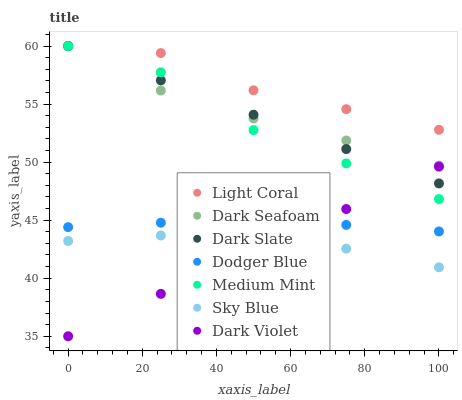Does Dark Violet have the minimum area under the curve?
Answer yes or no. Yes. Does Light Coral have the maximum area under the curve?
Answer yes or no. Yes. Does Light Coral have the minimum area under the curve?
Answer yes or no. No. Does Dark Violet have the maximum area under the curve?
Answer yes or no. No. Is Dark Violet the smoothest?
Answer yes or no. Yes. Is Medium Mint the roughest?
Answer yes or no. Yes. Is Light Coral the smoothest?
Answer yes or no. No. Is Light Coral the roughest?
Answer yes or no. No. Does Dark Violet have the lowest value?
Answer yes or no. Yes. Does Light Coral have the lowest value?
Answer yes or no. No. Does Dark Seafoam have the highest value?
Answer yes or no. Yes. Does Dark Violet have the highest value?
Answer yes or no. No. Is Dodger Blue less than Medium Mint?
Answer yes or no. Yes. Is Medium Mint greater than Sky Blue?
Answer yes or no. Yes. Does Dark Slate intersect Dark Seafoam?
Answer yes or no. Yes. Is Dark Slate less than Dark Seafoam?
Answer yes or no. No. Is Dark Slate greater than Dark Seafoam?
Answer yes or no. No. Does Dodger Blue intersect Medium Mint?
Answer yes or no. No. 